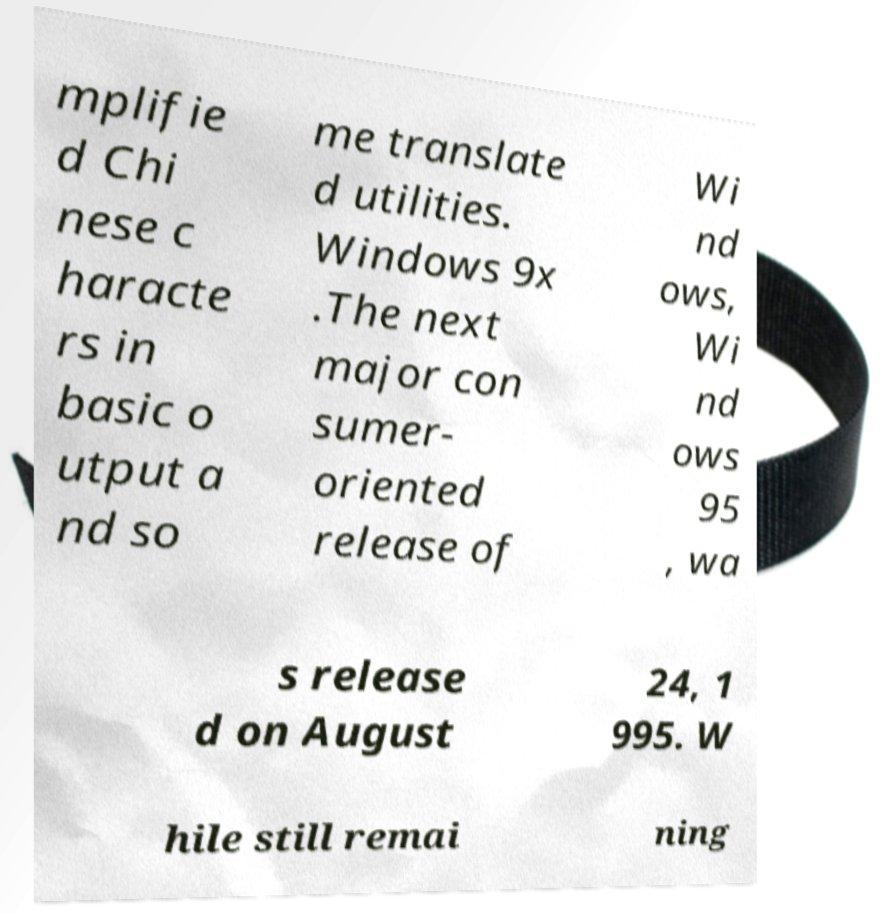There's text embedded in this image that I need extracted. Can you transcribe it verbatim? mplifie d Chi nese c haracte rs in basic o utput a nd so me translate d utilities. Windows 9x .The next major con sumer- oriented release of Wi nd ows, Wi nd ows 95 , wa s release d on August 24, 1 995. W hile still remai ning 